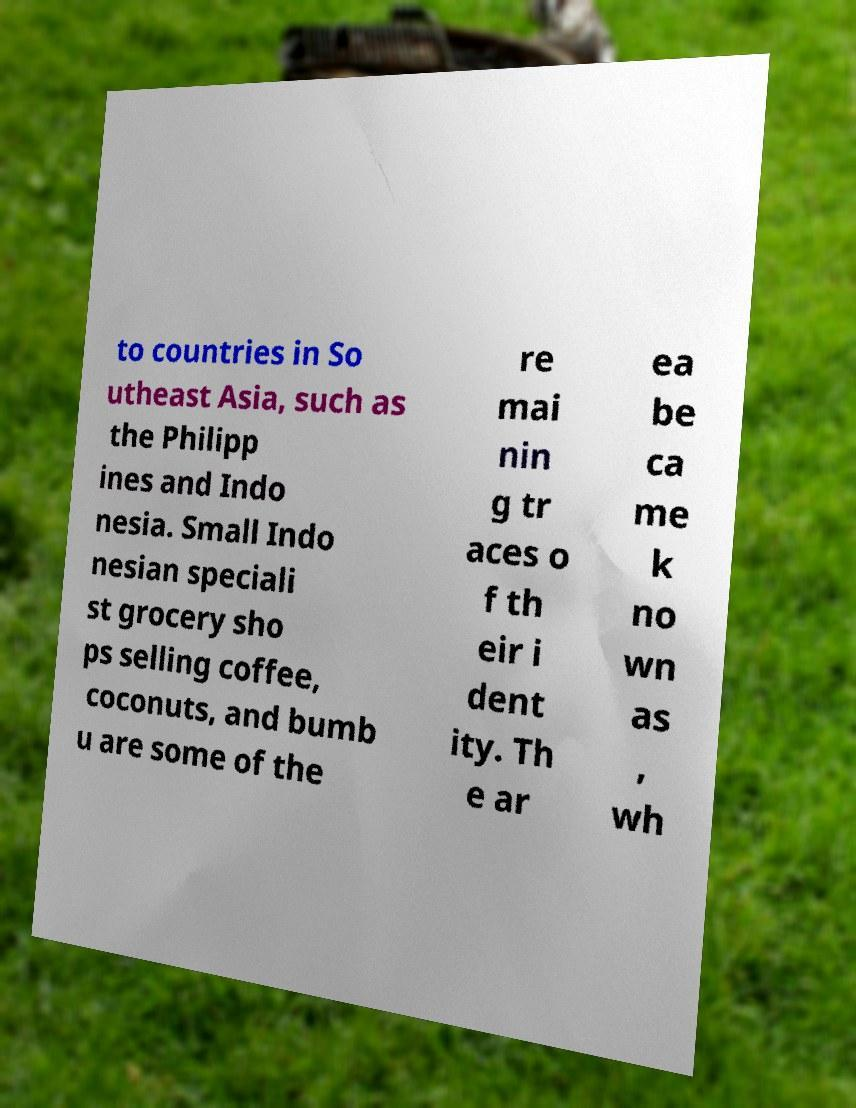Please read and relay the text visible in this image. What does it say? to countries in So utheast Asia, such as the Philipp ines and Indo nesia. Small Indo nesian speciali st grocery sho ps selling coffee, coconuts, and bumb u are some of the re mai nin g tr aces o f th eir i dent ity. Th e ar ea be ca me k no wn as , wh 